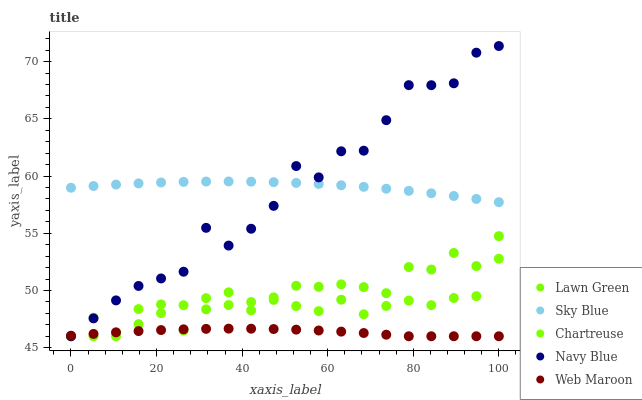Does Web Maroon have the minimum area under the curve?
Answer yes or no. Yes. Does Sky Blue have the maximum area under the curve?
Answer yes or no. Yes. Does Chartreuse have the minimum area under the curve?
Answer yes or no. No. Does Chartreuse have the maximum area under the curve?
Answer yes or no. No. Is Sky Blue the smoothest?
Answer yes or no. Yes. Is Lawn Green the roughest?
Answer yes or no. Yes. Is Chartreuse the smoothest?
Answer yes or no. No. Is Chartreuse the roughest?
Answer yes or no. No. Does Lawn Green have the lowest value?
Answer yes or no. Yes. Does Sky Blue have the lowest value?
Answer yes or no. No. Does Navy Blue have the highest value?
Answer yes or no. Yes. Does Chartreuse have the highest value?
Answer yes or no. No. Is Lawn Green less than Sky Blue?
Answer yes or no. Yes. Is Sky Blue greater than Lawn Green?
Answer yes or no. Yes. Does Sky Blue intersect Navy Blue?
Answer yes or no. Yes. Is Sky Blue less than Navy Blue?
Answer yes or no. No. Is Sky Blue greater than Navy Blue?
Answer yes or no. No. Does Lawn Green intersect Sky Blue?
Answer yes or no. No. 